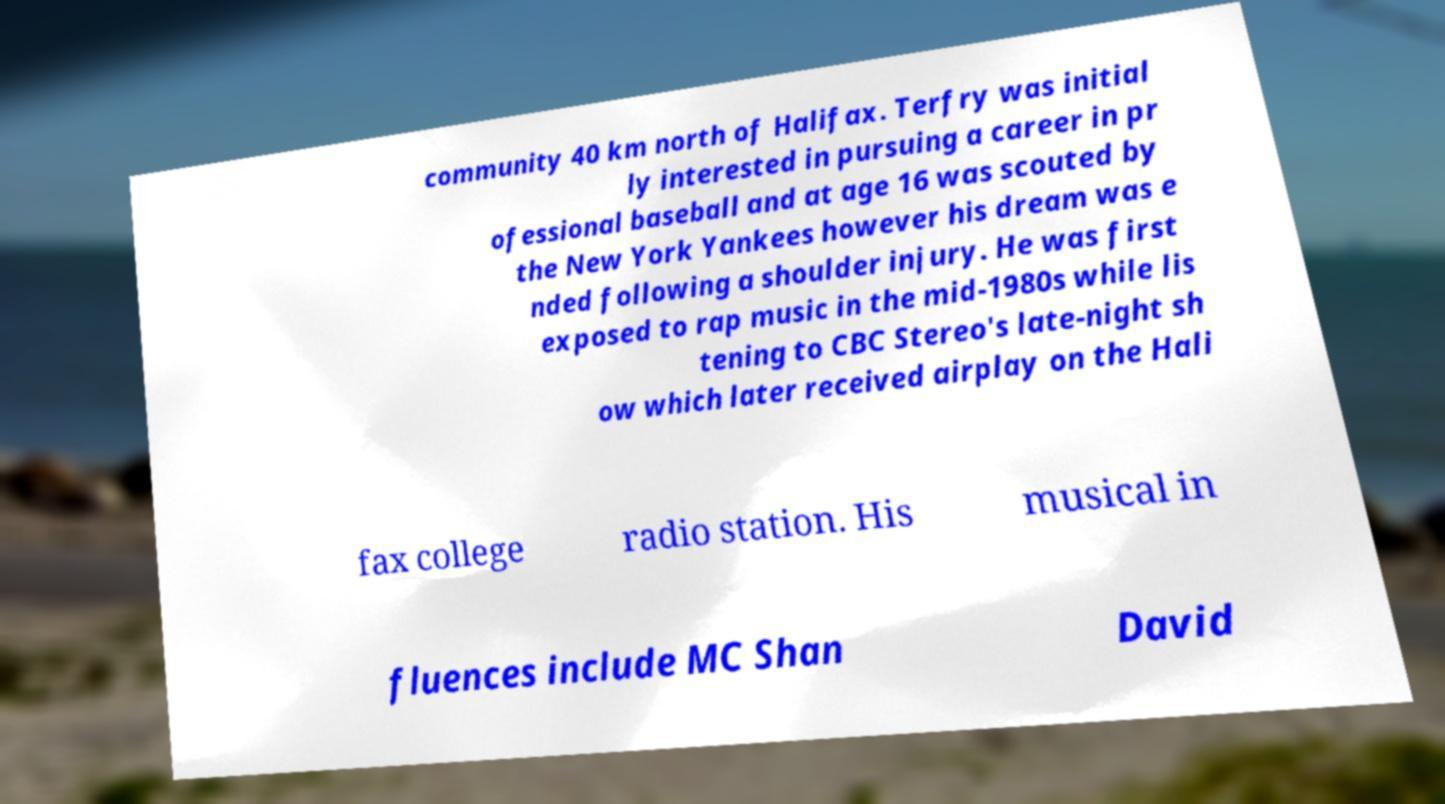Can you accurately transcribe the text from the provided image for me? community 40 km north of Halifax. Terfry was initial ly interested in pursuing a career in pr ofessional baseball and at age 16 was scouted by the New York Yankees however his dream was e nded following a shoulder injury. He was first exposed to rap music in the mid-1980s while lis tening to CBC Stereo's late-night sh ow which later received airplay on the Hali fax college radio station. His musical in fluences include MC Shan David 